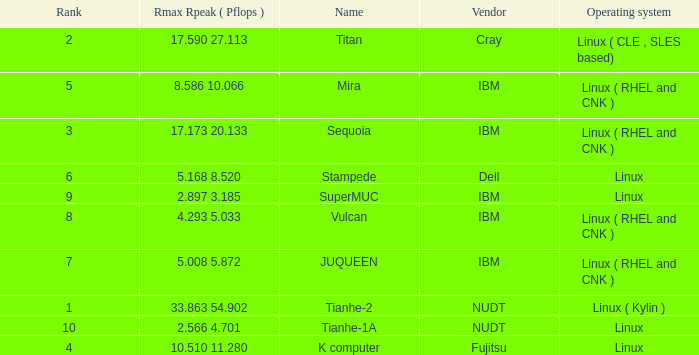What is the rank of Rmax Rpeak ( Pflops ) of 17.173 20.133? 3.0. 